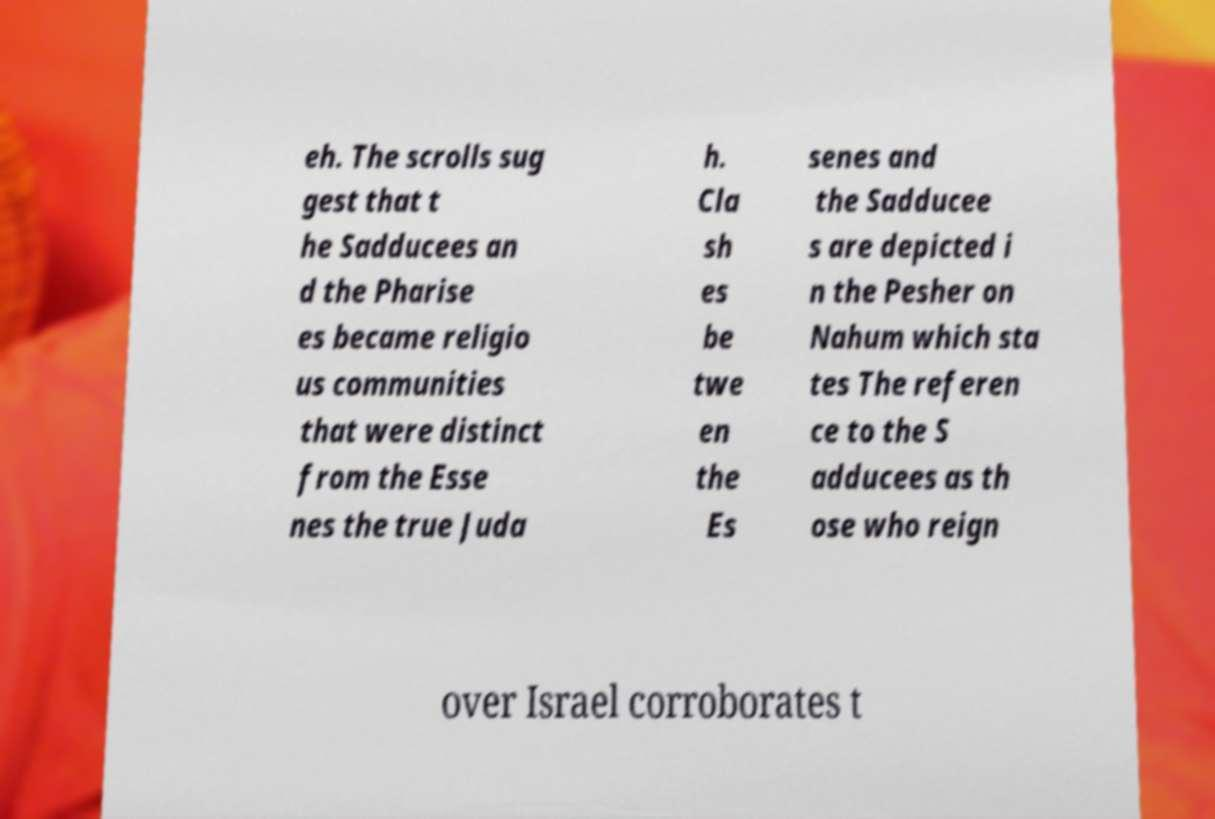For documentation purposes, I need the text within this image transcribed. Could you provide that? eh. The scrolls sug gest that t he Sadducees an d the Pharise es became religio us communities that were distinct from the Esse nes the true Juda h. Cla sh es be twe en the Es senes and the Sadducee s are depicted i n the Pesher on Nahum which sta tes The referen ce to the S adducees as th ose who reign over Israel corroborates t 